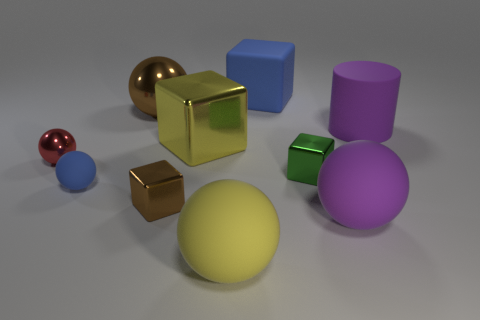Is there anything else that has the same material as the yellow sphere?
Ensure brevity in your answer.  Yes. What size is the purple thing that is behind the brown metallic object that is in front of the big metal object behind the large purple cylinder?
Give a very brief answer. Large. There is a brown cube; is its size the same as the yellow object behind the small shiny ball?
Give a very brief answer. No. There is a tiny metal block behind the tiny brown metal block; what is its color?
Give a very brief answer. Green. What shape is the large thing that is the same color as the small matte object?
Your answer should be very brief. Cube. There is a blue rubber object behind the tiny green metal cube; what is its shape?
Provide a short and direct response. Cube. What number of brown things are either tiny shiny cubes or shiny blocks?
Ensure brevity in your answer.  1. Is the material of the brown cube the same as the small red sphere?
Give a very brief answer. Yes. There is a large yellow rubber ball; what number of tiny things are to the right of it?
Offer a terse response. 1. What material is the tiny thing that is right of the brown sphere and behind the tiny blue rubber sphere?
Your answer should be very brief. Metal. 